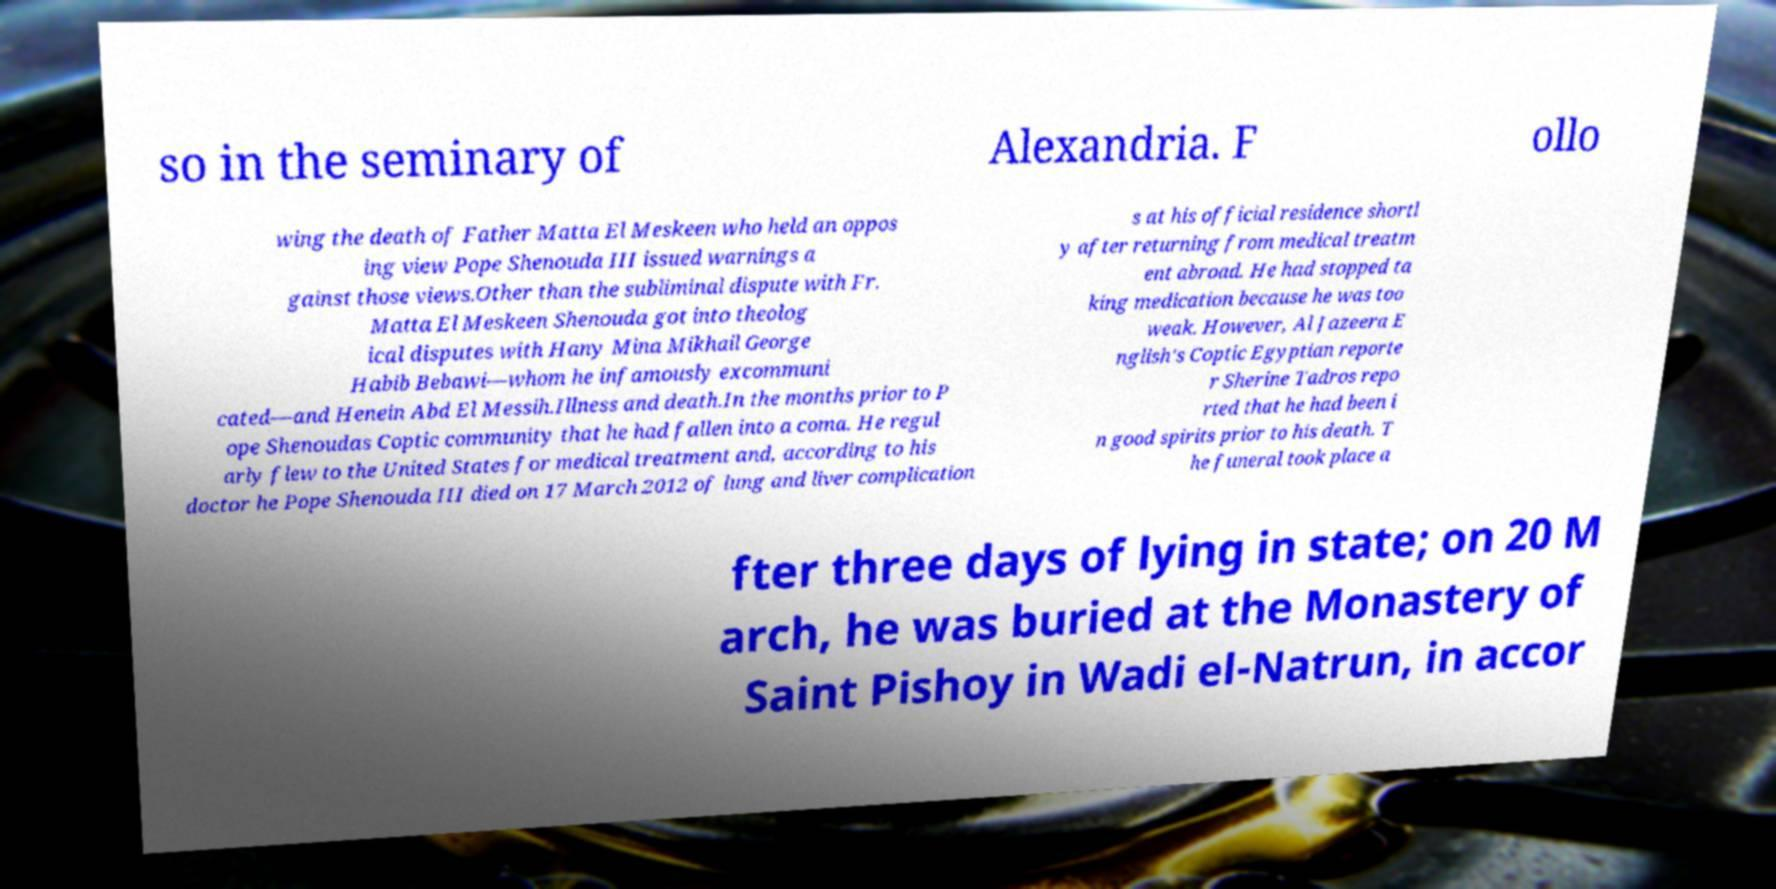Could you assist in decoding the text presented in this image and type it out clearly? so in the seminary of Alexandria. F ollo wing the death of Father Matta El Meskeen who held an oppos ing view Pope Shenouda III issued warnings a gainst those views.Other than the subliminal dispute with Fr. Matta El Meskeen Shenouda got into theolog ical disputes with Hany Mina Mikhail George Habib Bebawi—whom he infamously excommuni cated—and Henein Abd El Messih.Illness and death.In the months prior to P ope Shenoudas Coptic community that he had fallen into a coma. He regul arly flew to the United States for medical treatment and, according to his doctor he Pope Shenouda III died on 17 March 2012 of lung and liver complication s at his official residence shortl y after returning from medical treatm ent abroad. He had stopped ta king medication because he was too weak. However, Al Jazeera E nglish's Coptic Egyptian reporte r Sherine Tadros repo rted that he had been i n good spirits prior to his death. T he funeral took place a fter three days of lying in state; on 20 M arch, he was buried at the Monastery of Saint Pishoy in Wadi el-Natrun, in accor 